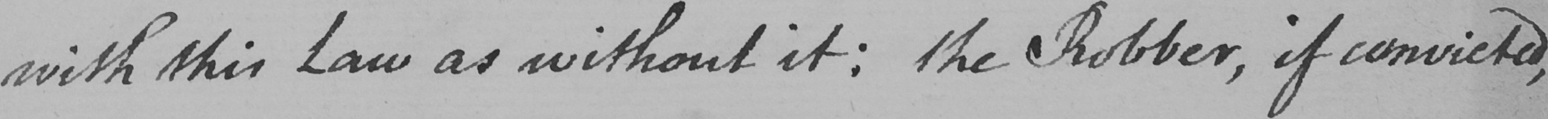Can you tell me what this handwritten text says? with this Law as without it :  the Robber , if convicted , 